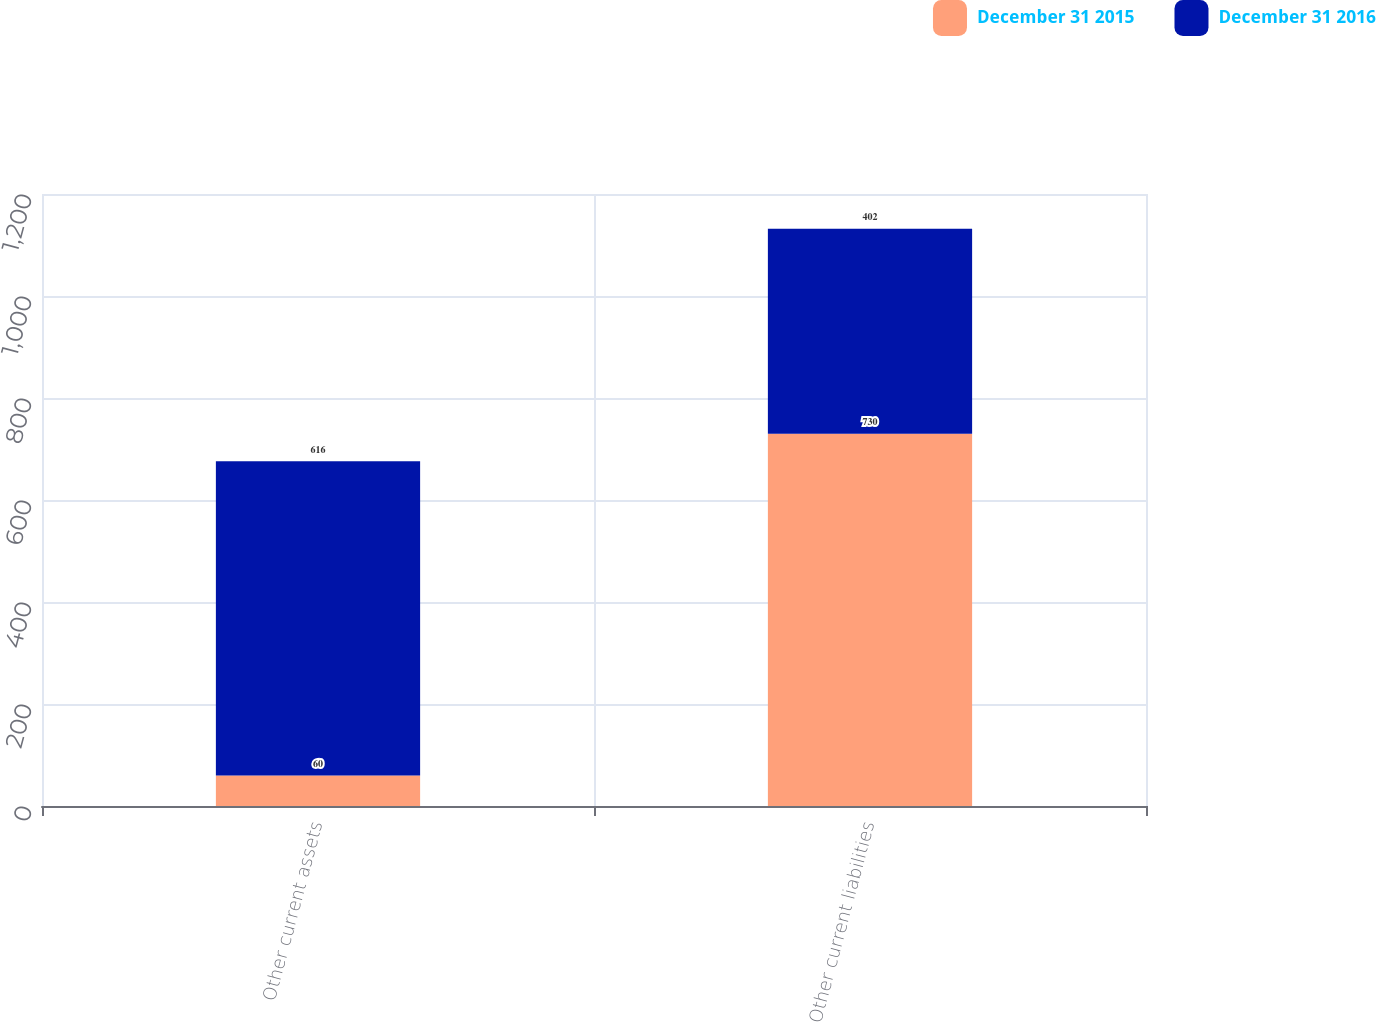Convert chart to OTSL. <chart><loc_0><loc_0><loc_500><loc_500><stacked_bar_chart><ecel><fcel>Other current assets<fcel>Other current liabilities<nl><fcel>December 31 2015<fcel>60<fcel>730<nl><fcel>December 31 2016<fcel>616<fcel>402<nl></chart> 